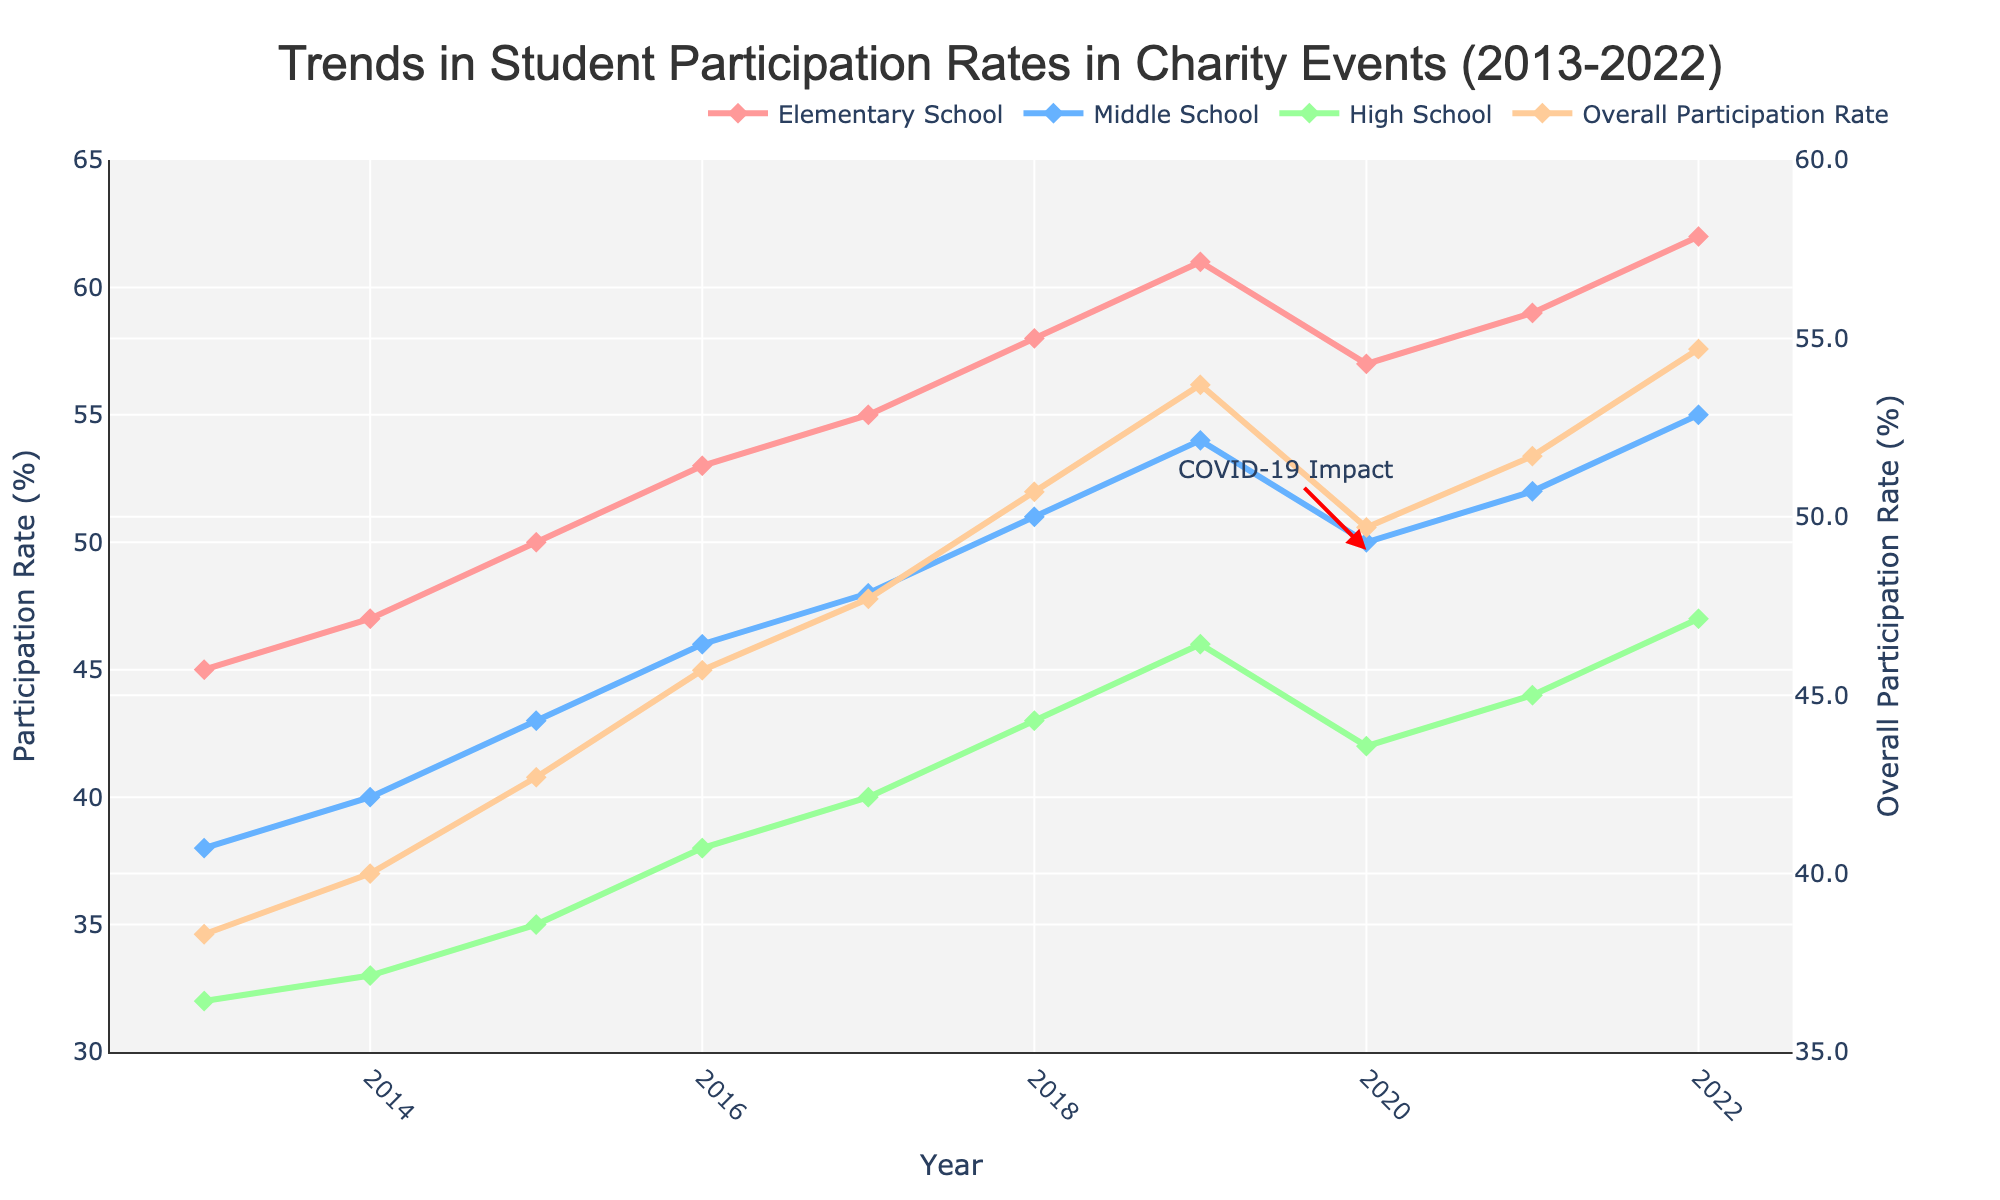What is the trend in elementary school participation rates from 2013 to 2022? To determine the trend, observe the line representing elementary school participation rates. The line starts at 45% in 2013 and rises steadily to 62% in 2022, showing a consistent increase over the years.
Answer: Increasing Which year saw the highest overall participation rate? To find the highest overall participation rate, look at the peaks of the unique line for overall participation rate. The highest rate is at 54.7% in 2022.
Answer: 2022 In which year did high school participation have the smallest increase compared to the previous year? To find the smallest increase, calculate the difference in high school participation between each consecutive year. The smallest increase is between 2014 and 2015: (33 - 32) = 1%.
Answer: 2014 to 2015 How did the COVID-19 pandemic affect overall participation rates in 2020? Look for the annotation on the graph marking "COVID-19 Impact" in 2020. Observe the drop in overall participation from 53.7% in 2019 to 49.7% in 2020.
Answer: It caused a decline What is the average overall participation rate from 2013 to 2022? To calculate the average, sum the overall participation rates for all years and divide by the number of years: (38.3 + 40.0 + 42.7 + 45.7 + 47.7 + 50.7 + 53.7 + 49.7 + 51.7 + 54.7)/10 = 47.5%
Answer: 47.5% Which school level shows the most significant growth in participation from 2013 to 2022? Compare the starting and ending points of the lines for each school level. Elementary School grows from 45% to 62%, which is the largest increase of 17 percentage points, more than Middle School and High School.
Answer: Elementary School How did middle school participation change from 2020 to 2022? Locate the middle school participation rate for 2020 and 2022. In 2020, the rate is 50%, and in 2022, it is 55%. The change is an increase of (55-50)=5%.
Answer: Increased by 5% Compare the overall participation rate trend to high school participation trend from 2016 to 2021. Observe the line trends for overall participation and high school participation from 2016 to 2021. While both are increasing, overall participation has more fluctuations, notably the drop in 2020, and rebounds, while high school participation shows a steady, though slower increase.
Answer: The overall trend has more fluctuations but generally follows a similar upward pattern What is the difference between elementary and high school participation rates in 2022? Subtract the high school participation rate in 2022 from the elementary school rate in 2022: 62% - 47% = 15%.
Answer: 15% 